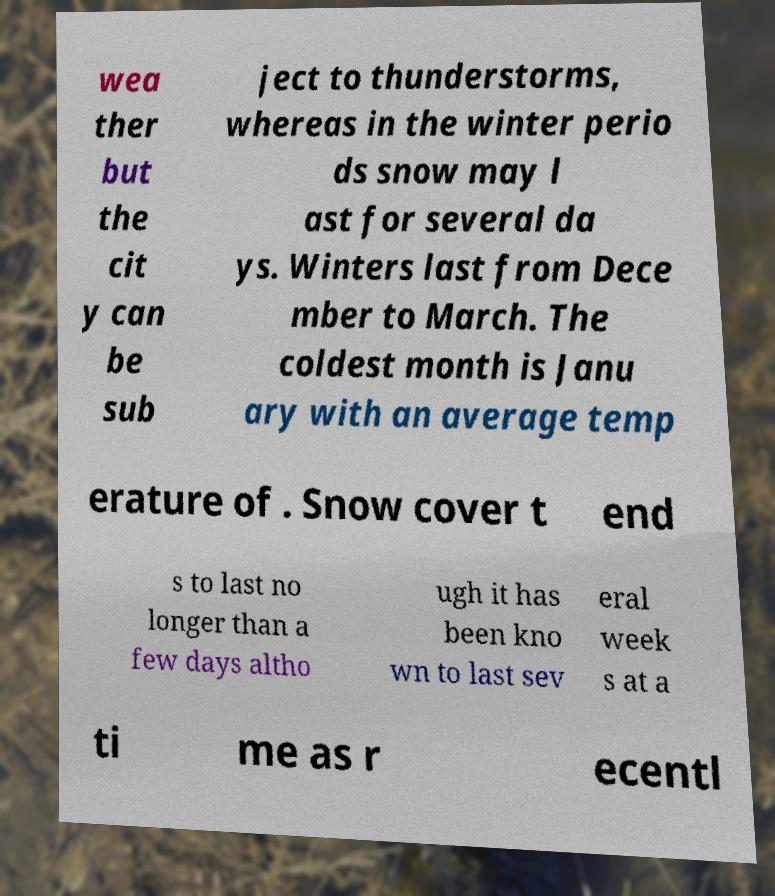Please read and relay the text visible in this image. What does it say? wea ther but the cit y can be sub ject to thunderstorms, whereas in the winter perio ds snow may l ast for several da ys. Winters last from Dece mber to March. The coldest month is Janu ary with an average temp erature of . Snow cover t end s to last no longer than a few days altho ugh it has been kno wn to last sev eral week s at a ti me as r ecentl 